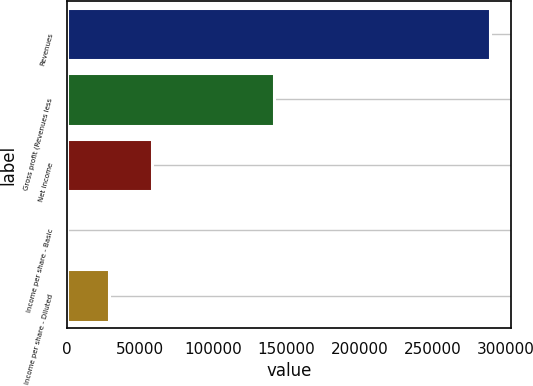<chart> <loc_0><loc_0><loc_500><loc_500><bar_chart><fcel>Revenues<fcel>Gross profit (Revenues less<fcel>Net income<fcel>Income per share - Basic<fcel>Income per share - Diluted<nl><fcel>289465<fcel>141383<fcel>57893.1<fcel>0.16<fcel>28946.6<nl></chart> 